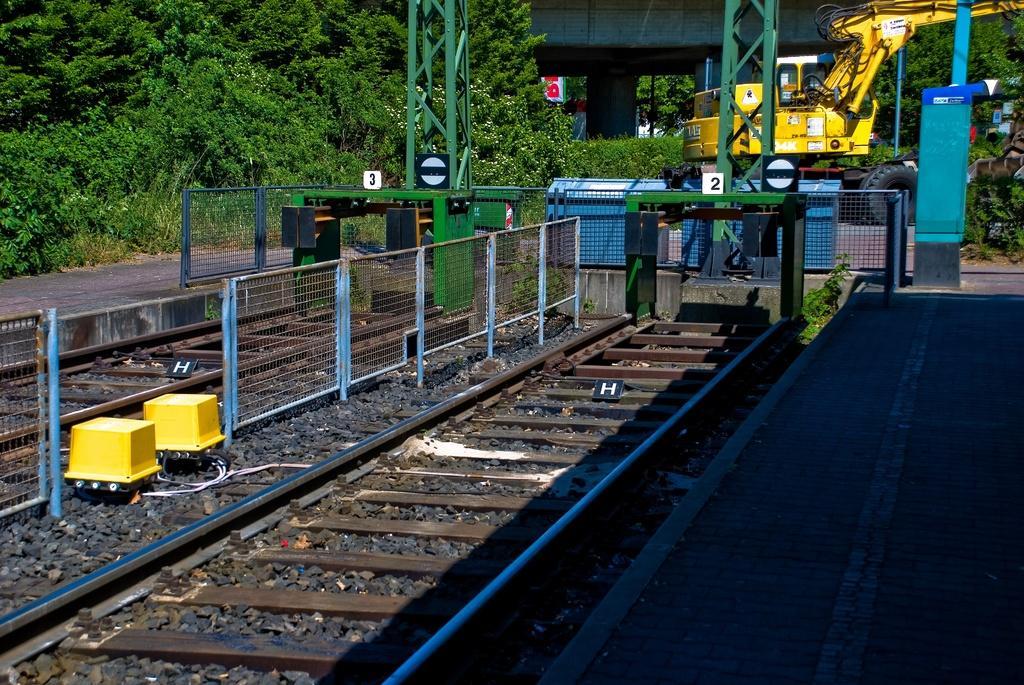Can you describe this image briefly? In this picture we can see a platform on the right side. There is a railway track. We can see a letter on the black objects. There are two yellow objects. We can see some fencing and colorful objects are visible from left to right. There is a vehicle, plants, trees, a pillar and other objects are visible in the background. 